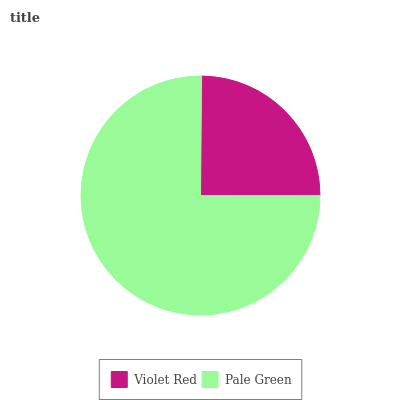Is Violet Red the minimum?
Answer yes or no. Yes. Is Pale Green the maximum?
Answer yes or no. Yes. Is Pale Green the minimum?
Answer yes or no. No. Is Pale Green greater than Violet Red?
Answer yes or no. Yes. Is Violet Red less than Pale Green?
Answer yes or no. Yes. Is Violet Red greater than Pale Green?
Answer yes or no. No. Is Pale Green less than Violet Red?
Answer yes or no. No. Is Pale Green the high median?
Answer yes or no. Yes. Is Violet Red the low median?
Answer yes or no. Yes. Is Violet Red the high median?
Answer yes or no. No. Is Pale Green the low median?
Answer yes or no. No. 